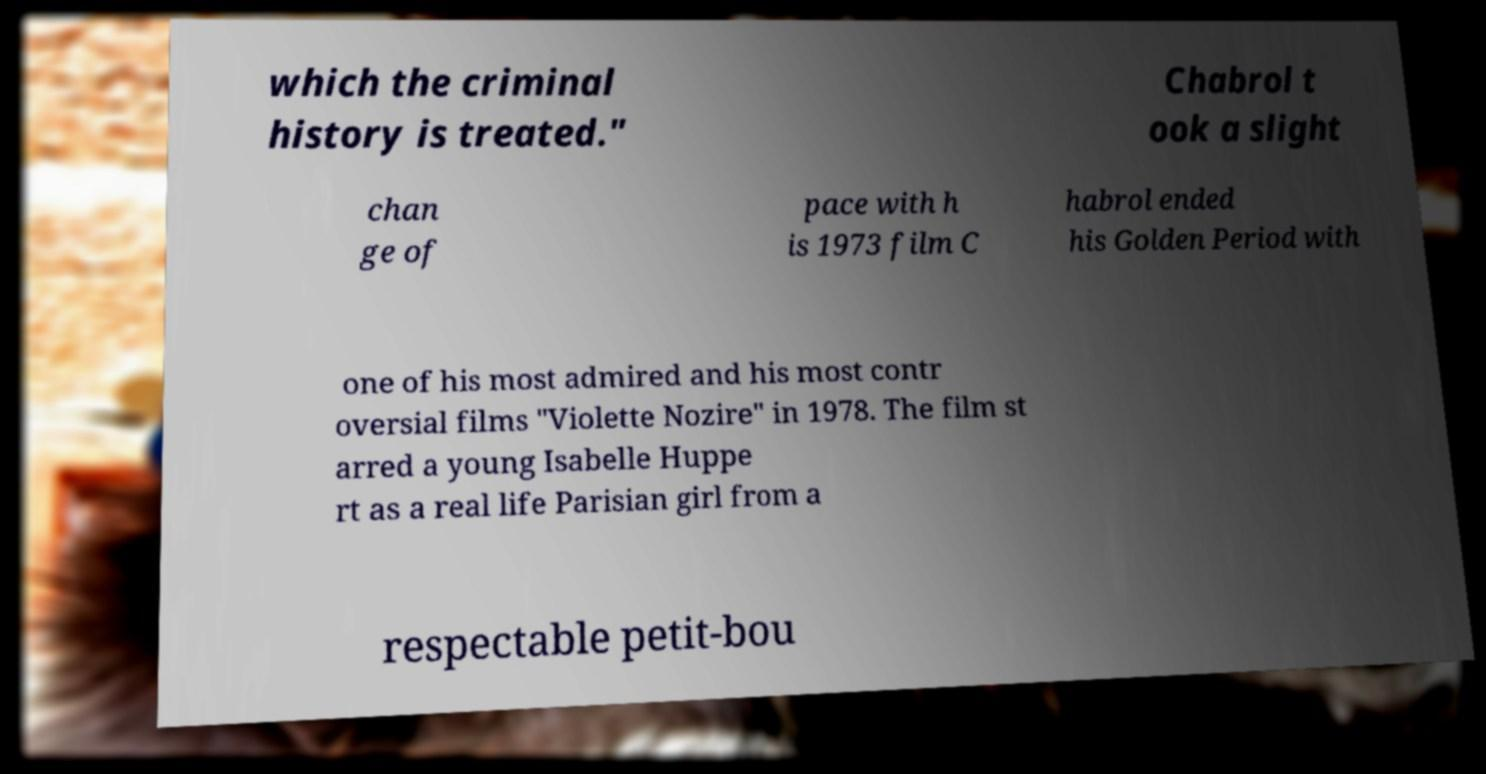Could you assist in decoding the text presented in this image and type it out clearly? which the criminal history is treated." Chabrol t ook a slight chan ge of pace with h is 1973 film C habrol ended his Golden Period with one of his most admired and his most contr oversial films "Violette Nozire" in 1978. The film st arred a young Isabelle Huppe rt as a real life Parisian girl from a respectable petit-bou 